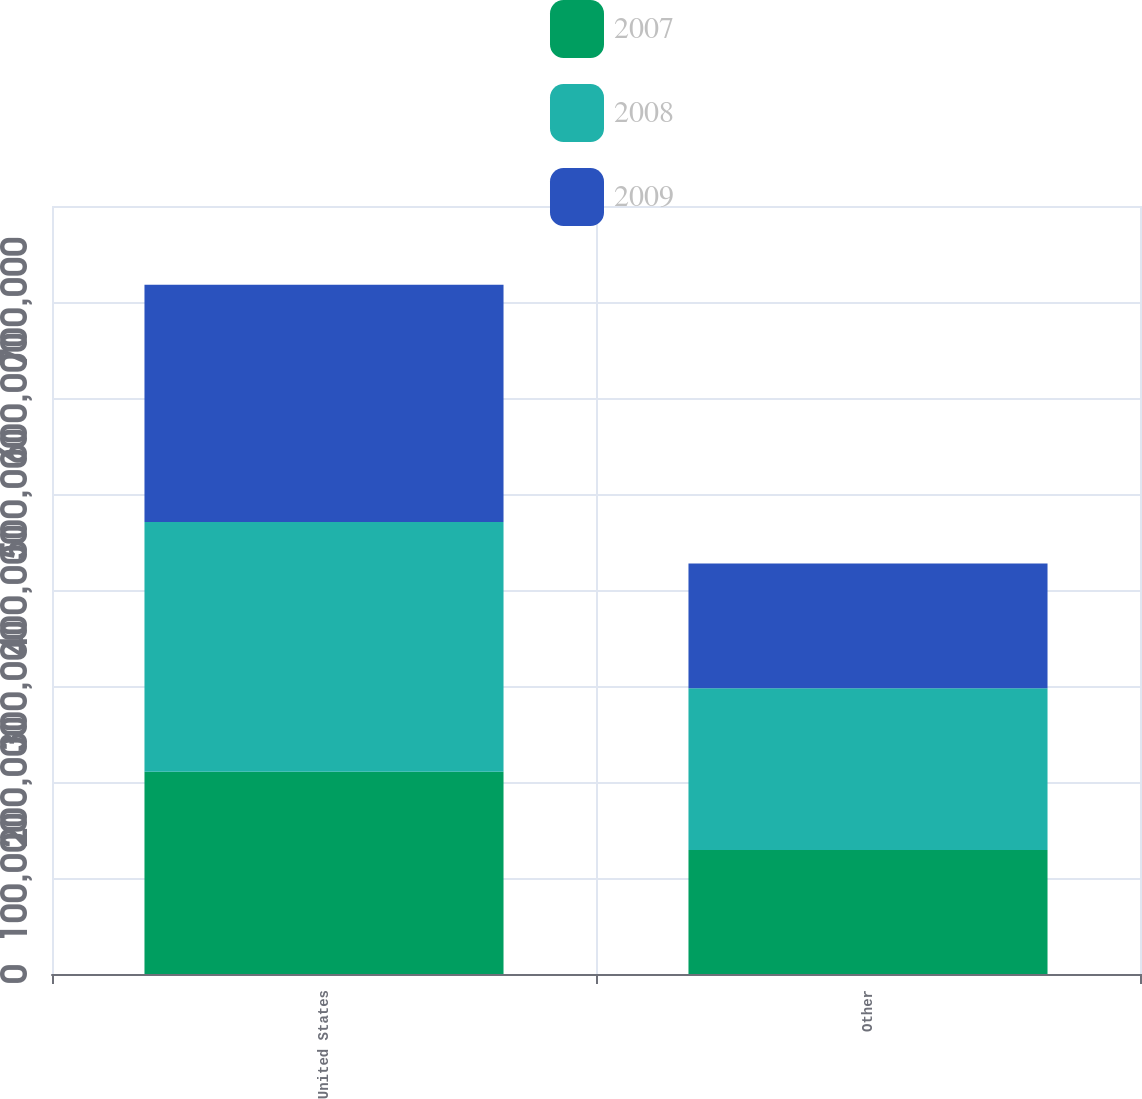Convert chart. <chart><loc_0><loc_0><loc_500><loc_500><stacked_bar_chart><ecel><fcel>United States<fcel>Other<nl><fcel>2007<fcel>210559<fcel>129209<nl><fcel>2008<fcel>260247<fcel>168569<nl><fcel>2009<fcel>247181<fcel>129816<nl></chart> 